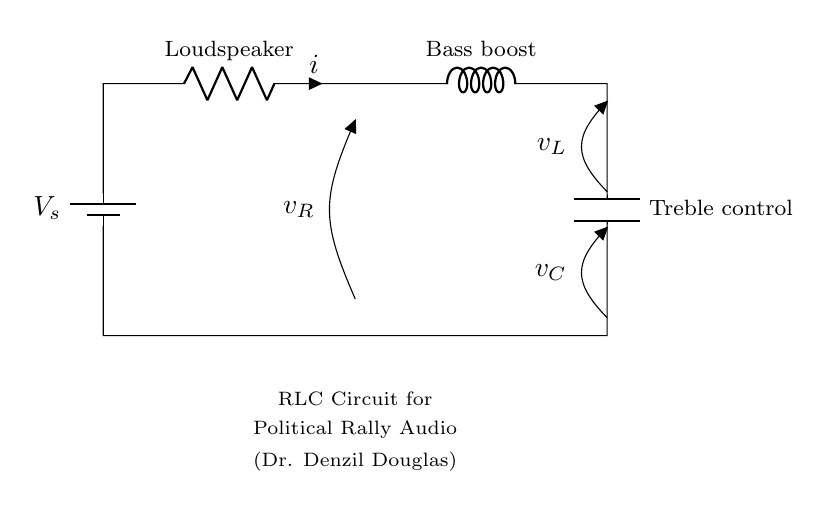What is the voltage source in this circuit? The voltage source is labeled as V_s at the top left of the circuit diagram, indicating the input voltage supplied to the circuit.
Answer: V_s What component is responsible for bass boost? The component responsible for bass boost is labeled as L, which stands for the inductor in the circuit. This inductor is used to enhance low-frequency signals for better bass response.
Answer: L What does C represent in this circuit? C represents the capacitor, specifically labeled as Treble control, which adjusts the high-frequency signals in the audio system to optimize sound quality.
Answer: C What is the current flowing through the loudspeaker? The current flowing through the loudspeaker is indicated by the symbol 'i' next to the loudspeaker in the circuit diagram. This shows how much current is passing through that component.
Answer: i How might the combination of L and C affect audio quality? The combination of L and C creates a tuned circuit that can filter specific frequencies, enhancing the overall audio quality by allowing desirable frequencies to pass while attenuating unwanted ones.
Answer: Improves audio quality What is the purpose of the RLC circuit in the context of a political rally? The RLC circuit's purpose is to optimize audio equipment at political rallies, ensuring that sound quality is clear and effective for communication, especially for speeches by figures like Dr. Denzil Douglas.
Answer: Optimize audio What might happen if L is increased in value? Increasing L would raise the inductance, possibly enhancing low-frequency performance but could also cause phase shifts and affect resonance, altering the sound characteristics of the audio system.
Answer: Alters sound characteristics 